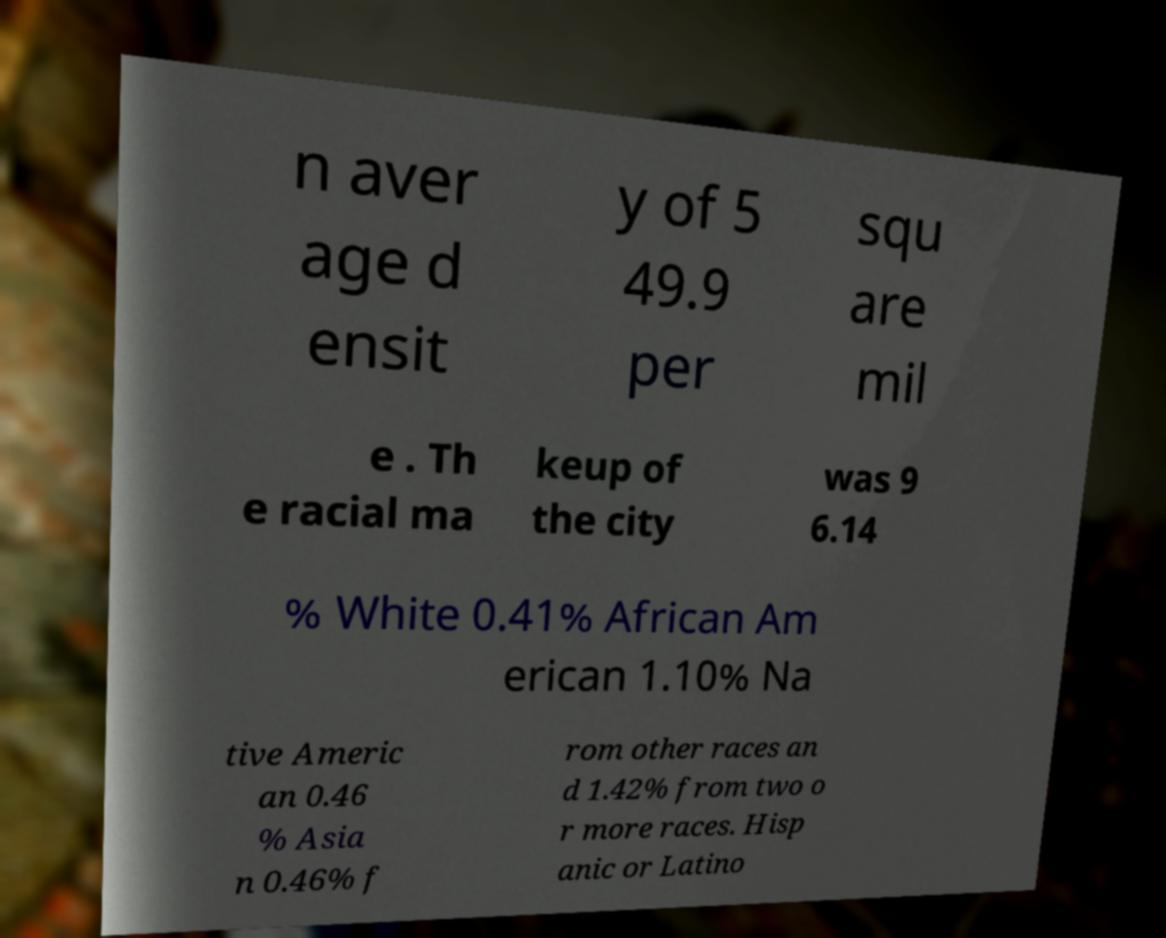There's text embedded in this image that I need extracted. Can you transcribe it verbatim? n aver age d ensit y of 5 49.9 per squ are mil e . Th e racial ma keup of the city was 9 6.14 % White 0.41% African Am erican 1.10% Na tive Americ an 0.46 % Asia n 0.46% f rom other races an d 1.42% from two o r more races. Hisp anic or Latino 